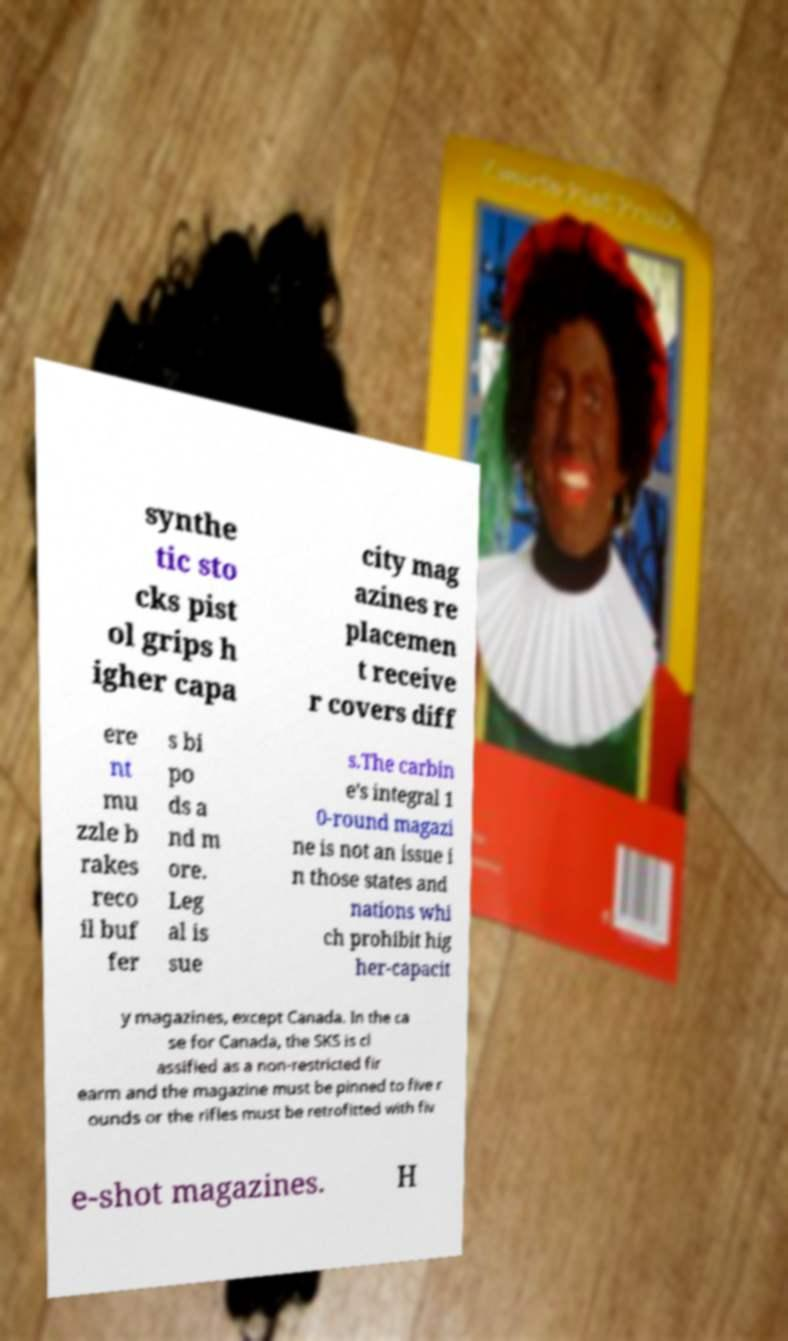For documentation purposes, I need the text within this image transcribed. Could you provide that? synthe tic sto cks pist ol grips h igher capa city mag azines re placemen t receive r covers diff ere nt mu zzle b rakes reco il buf fer s bi po ds a nd m ore. Leg al is sue s.The carbin e's integral 1 0-round magazi ne is not an issue i n those states and nations whi ch prohibit hig her-capacit y magazines, except Canada. In the ca se for Canada, the SKS is cl assified as a non-restricted fir earm and the magazine must be pinned to five r ounds or the rifles must be retrofitted with fiv e-shot magazines. H 